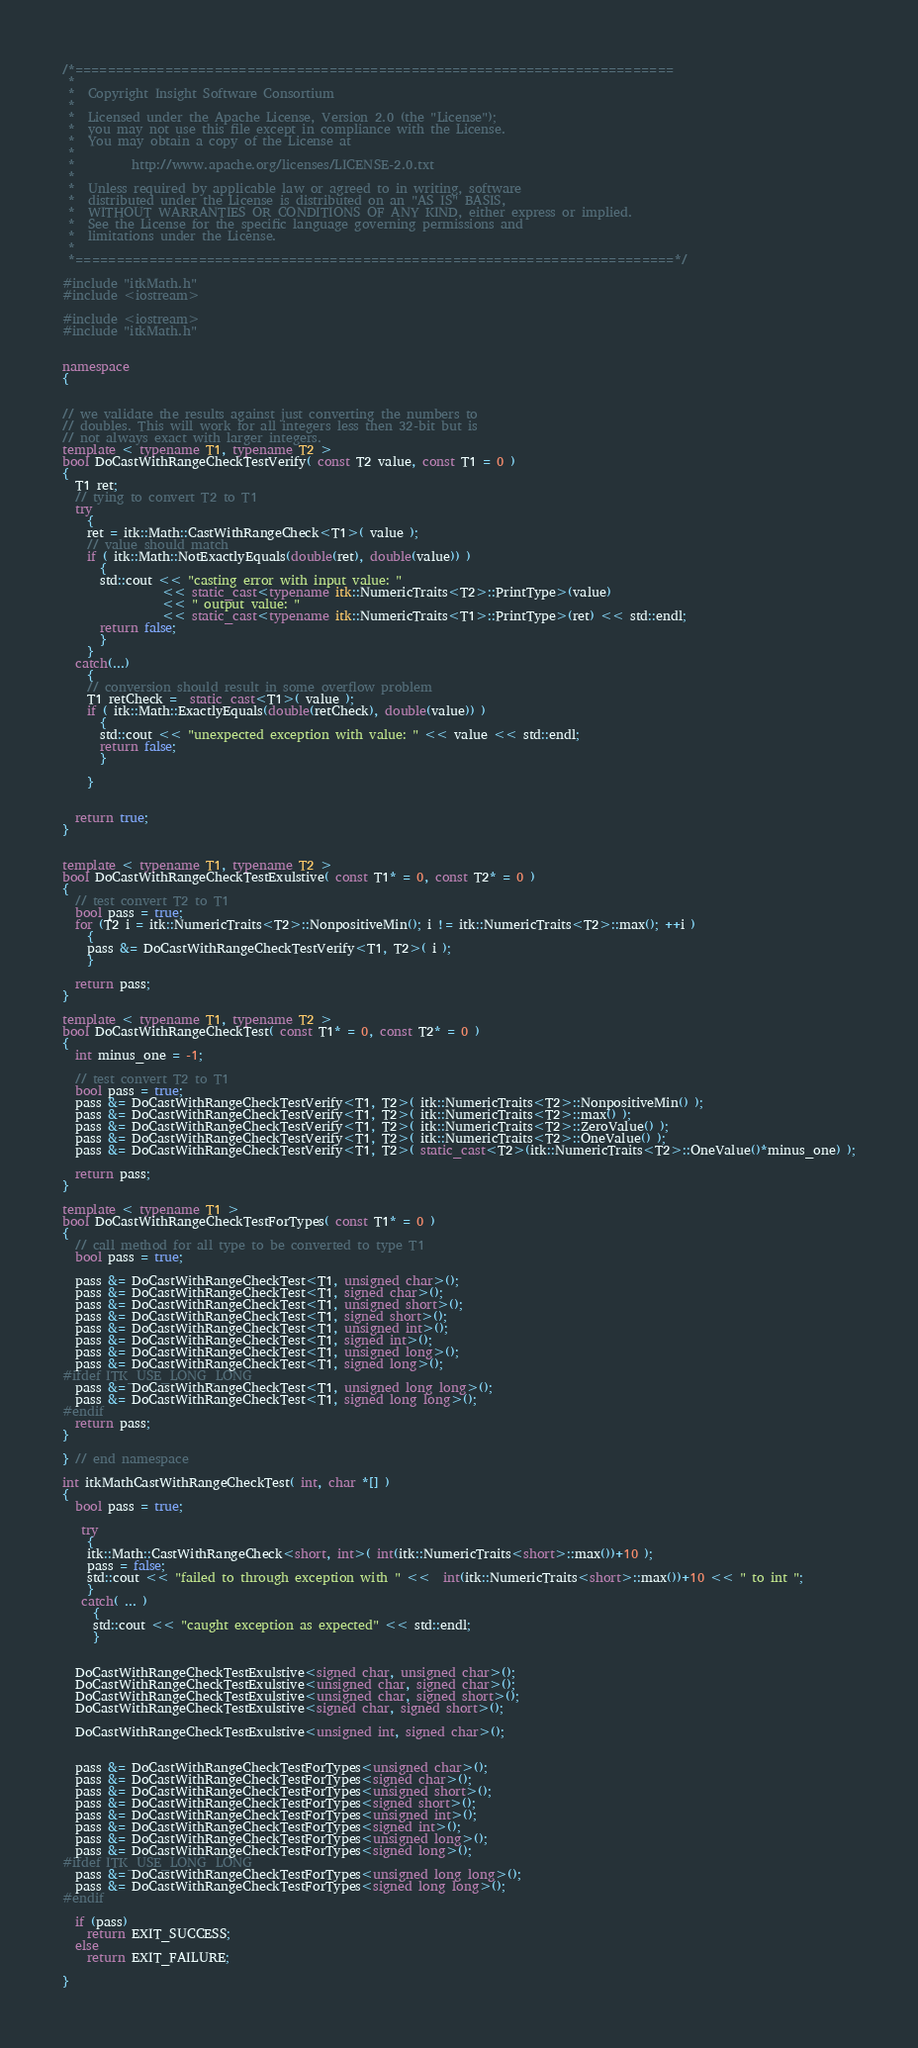Convert code to text. <code><loc_0><loc_0><loc_500><loc_500><_C++_>/*=========================================================================
 *
 *  Copyright Insight Software Consortium
 *
 *  Licensed under the Apache License, Version 2.0 (the "License");
 *  you may not use this file except in compliance with the License.
 *  You may obtain a copy of the License at
 *
 *         http://www.apache.org/licenses/LICENSE-2.0.txt
 *
 *  Unless required by applicable law or agreed to in writing, software
 *  distributed under the License is distributed on an "AS IS" BASIS,
 *  WITHOUT WARRANTIES OR CONDITIONS OF ANY KIND, either express or implied.
 *  See the License for the specific language governing permissions and
 *  limitations under the License.
 *
 *=========================================================================*/

#include "itkMath.h"
#include <iostream>

#include <iostream>
#include "itkMath.h"


namespace
{


// we validate the results against just converting the numbers to
// doubles. This will work for all integers less then 32-bit but is
// not always exact with larger integers.
template < typename T1, typename T2 >
bool DoCastWithRangeCheckTestVerify( const T2 value, const T1 = 0 )
{
  T1 ret;
  // tying to convert T2 to T1
  try
    {
    ret = itk::Math::CastWithRangeCheck<T1>( value );
    // value should match
    if ( itk::Math::NotExactlyEquals(double(ret), double(value)) )
      {
      std::cout << "casting error with input value: "
                << static_cast<typename itk::NumericTraits<T2>::PrintType>(value)
                << " output value: "
                << static_cast<typename itk::NumericTraits<T1>::PrintType>(ret) << std::endl;
      return false;
      }
    }
  catch(...)
    {
    // conversion should result in some overflow problem
    T1 retCheck =  static_cast<T1>( value );
    if ( itk::Math::ExactlyEquals(double(retCheck), double(value)) )
      {
      std::cout << "unexpected exception with value: " << value << std::endl;
      return false;
      }

    }


  return true;
}


template < typename T1, typename T2 >
bool DoCastWithRangeCheckTestExulstive( const T1* = 0, const T2* = 0 )
{
  // test convert T2 to T1
  bool pass = true;
  for (T2 i = itk::NumericTraits<T2>::NonpositiveMin(); i != itk::NumericTraits<T2>::max(); ++i )
    {
    pass &= DoCastWithRangeCheckTestVerify<T1, T2>( i );
    }

  return pass;
}

template < typename T1, typename T2 >
bool DoCastWithRangeCheckTest( const T1* = 0, const T2* = 0 )
{
  int minus_one = -1;

  // test convert T2 to T1
  bool pass = true;
  pass &= DoCastWithRangeCheckTestVerify<T1, T2>( itk::NumericTraits<T2>::NonpositiveMin() );
  pass &= DoCastWithRangeCheckTestVerify<T1, T2>( itk::NumericTraits<T2>::max() );
  pass &= DoCastWithRangeCheckTestVerify<T1, T2>( itk::NumericTraits<T2>::ZeroValue() );
  pass &= DoCastWithRangeCheckTestVerify<T1, T2>( itk::NumericTraits<T2>::OneValue() );
  pass &= DoCastWithRangeCheckTestVerify<T1, T2>( static_cast<T2>(itk::NumericTraits<T2>::OneValue()*minus_one) );

  return pass;
}

template < typename T1 >
bool DoCastWithRangeCheckTestForTypes( const T1* = 0 )
{
  // call method for all type to be converted to type T1
  bool pass = true;

  pass &= DoCastWithRangeCheckTest<T1, unsigned char>();
  pass &= DoCastWithRangeCheckTest<T1, signed char>();
  pass &= DoCastWithRangeCheckTest<T1, unsigned short>();
  pass &= DoCastWithRangeCheckTest<T1, signed short>();
  pass &= DoCastWithRangeCheckTest<T1, unsigned int>();
  pass &= DoCastWithRangeCheckTest<T1, signed int>();
  pass &= DoCastWithRangeCheckTest<T1, unsigned long>();
  pass &= DoCastWithRangeCheckTest<T1, signed long>();
#ifdef ITK_USE_LONG_LONG
  pass &= DoCastWithRangeCheckTest<T1, unsigned long long>();
  pass &= DoCastWithRangeCheckTest<T1, signed long long>();
#endif
  return pass;
}

} // end namespace

int itkMathCastWithRangeCheckTest( int, char *[] )
{
  bool pass = true;

   try
    {
    itk::Math::CastWithRangeCheck<short, int>( int(itk::NumericTraits<short>::max())+10 );
    pass = false;
    std::cout << "failed to through exception with " <<  int(itk::NumericTraits<short>::max())+10 << " to int ";
    }
   catch( ... )
     {
     std::cout << "caught exception as expected" << std::endl;
     }


  DoCastWithRangeCheckTestExulstive<signed char, unsigned char>();
  DoCastWithRangeCheckTestExulstive<unsigned char, signed char>();
  DoCastWithRangeCheckTestExulstive<unsigned char, signed short>();
  DoCastWithRangeCheckTestExulstive<signed char, signed short>();

  DoCastWithRangeCheckTestExulstive<unsigned int, signed char>();


  pass &= DoCastWithRangeCheckTestForTypes<unsigned char>();
  pass &= DoCastWithRangeCheckTestForTypes<signed char>();
  pass &= DoCastWithRangeCheckTestForTypes<unsigned short>();
  pass &= DoCastWithRangeCheckTestForTypes<signed short>();
  pass &= DoCastWithRangeCheckTestForTypes<unsigned int>();
  pass &= DoCastWithRangeCheckTestForTypes<signed int>();
  pass &= DoCastWithRangeCheckTestForTypes<unsigned long>();
  pass &= DoCastWithRangeCheckTestForTypes<signed long>();
#ifdef ITK_USE_LONG_LONG
  pass &= DoCastWithRangeCheckTestForTypes<unsigned long long>();
  pass &= DoCastWithRangeCheckTestForTypes<signed long long>();
#endif

  if (pass)
    return EXIT_SUCCESS;
  else
    return EXIT_FAILURE;

}
</code> 